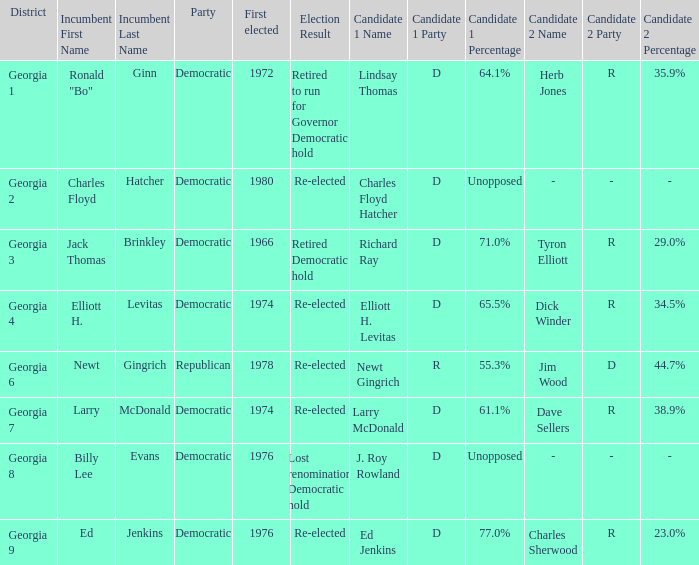Name the candidates for georgia 8 J. Roy Rowland (D) Unopposed. 